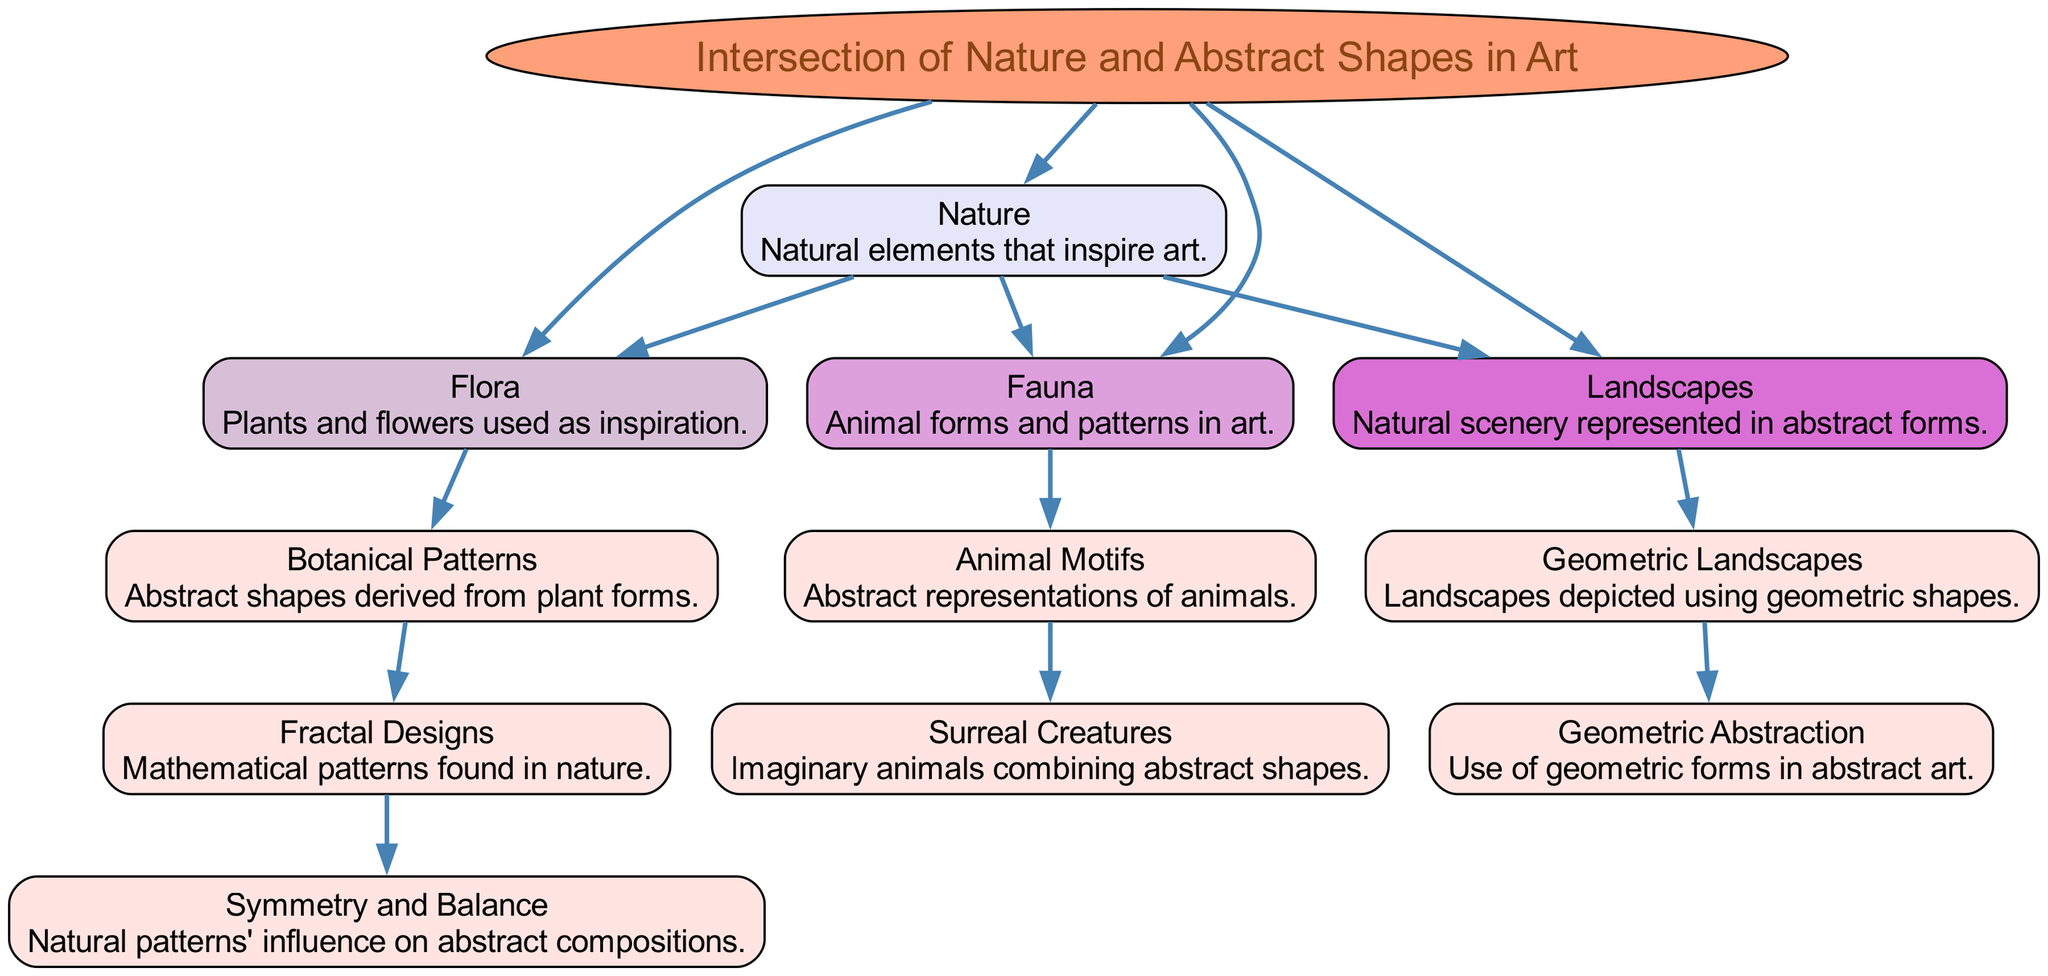What is the main topic of the concept map? The main topic is shown at the center of the diagram, labeled "Intersection of Nature and Abstract Shapes in Art." It is the central idea connecting all other elements.
Answer: Intersection of Nature and Abstract Shapes in Art How many main elements are connected to the main topic? The number of direct connections to the main topic can be counted by reviewing the edges leading from the main topic to the elements. There are four main elements: Flora, Fauna, Landscapes, and Nature.
Answer: 4 Which element is described as "Abstract shapes derived from plant forms"? Looking through the descriptions in the diagram, that phrase corresponds to the element "Botanical Patterns." It explicitly states this as its description.
Answer: Botanical Patterns What are the connections of the "Fauna" element? To find the connections of the "Fauna" element, we look at the edges stemming from it. It connects to one other element: "Animal Motifs."
Answer: Animal Motifs What color is used for the "Geometric Landscapes" node? The color of the "Geometric Landscapes" node can be identified by examining the visual representation in the diagram. It is filled with the color corresponding to depth, specifically a light color indicated in the diagram.
Answer: #FFE4E1 How does "Surreal Creatures" relate to the "Intersection of Nature and Abstract Shapes in Art"? To analyze this relationship, we can trace back the connections beginning with "Surreal Creatures." It is linked through other elements, but as there are no outgoing connections from it, it does not directly relate back to the main topic.
Answer: No direct relationship Which element combines mathematical patterns found in nature? The description that focuses on mathematical patterns indicates it is related to "Fractal Designs." By examining the connections, it can be confirmed to be this specific element.
Answer: Fractal Designs What has a direct connection with "Geometric Abstraction"? By reviewing the edges leading from the element "Geometric Abstraction," it is evident that this node has no edges connecting to other elements, meaning it stands as an isolated concept in the diagram.
Answer: No direct connections 